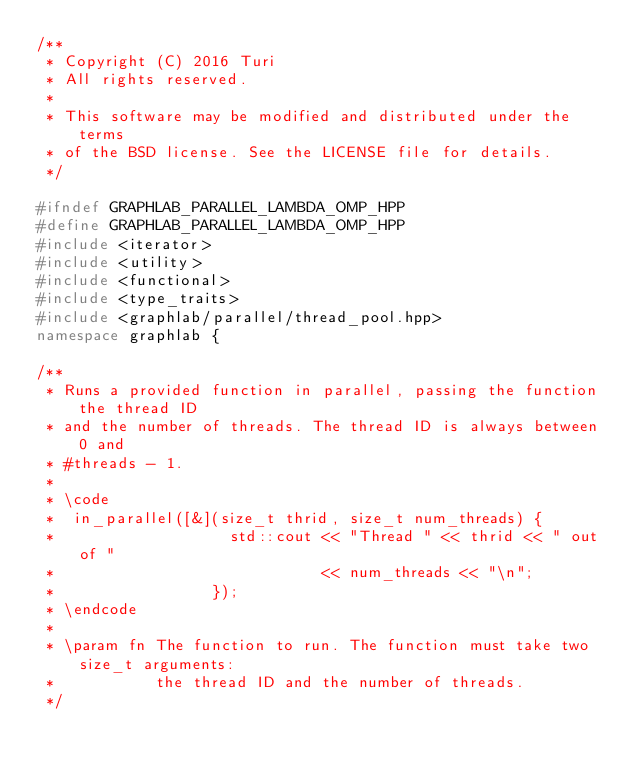<code> <loc_0><loc_0><loc_500><loc_500><_C++_>/**
 * Copyright (C) 2016 Turi
 * All rights reserved.
 *
 * This software may be modified and distributed under the terms
 * of the BSD license. See the LICENSE file for details.
 */

#ifndef GRAPHLAB_PARALLEL_LAMBDA_OMP_HPP
#define GRAPHLAB_PARALLEL_LAMBDA_OMP_HPP
#include <iterator>
#include <utility>
#include <functional>
#include <type_traits>
#include <graphlab/parallel/thread_pool.hpp>
namespace graphlab {

/**
 * Runs a provided function in parallel, passing the function the thread ID 
 * and the number of threads. The thread ID is always between 0 and 
 * #threads - 1. 
 *
 * \code
 *  in_parallel([&](size_t thrid, size_t num_threads) {
 *                   std::cout << "Thread " << thrid << " out of " 
 *                             << num_threads << "\n";
 *                 });
 * \endcode
 *
 * \param fn The function to run. The function must take two size_t arguments:
 *           the thread ID and the number of threads.
 */</code> 